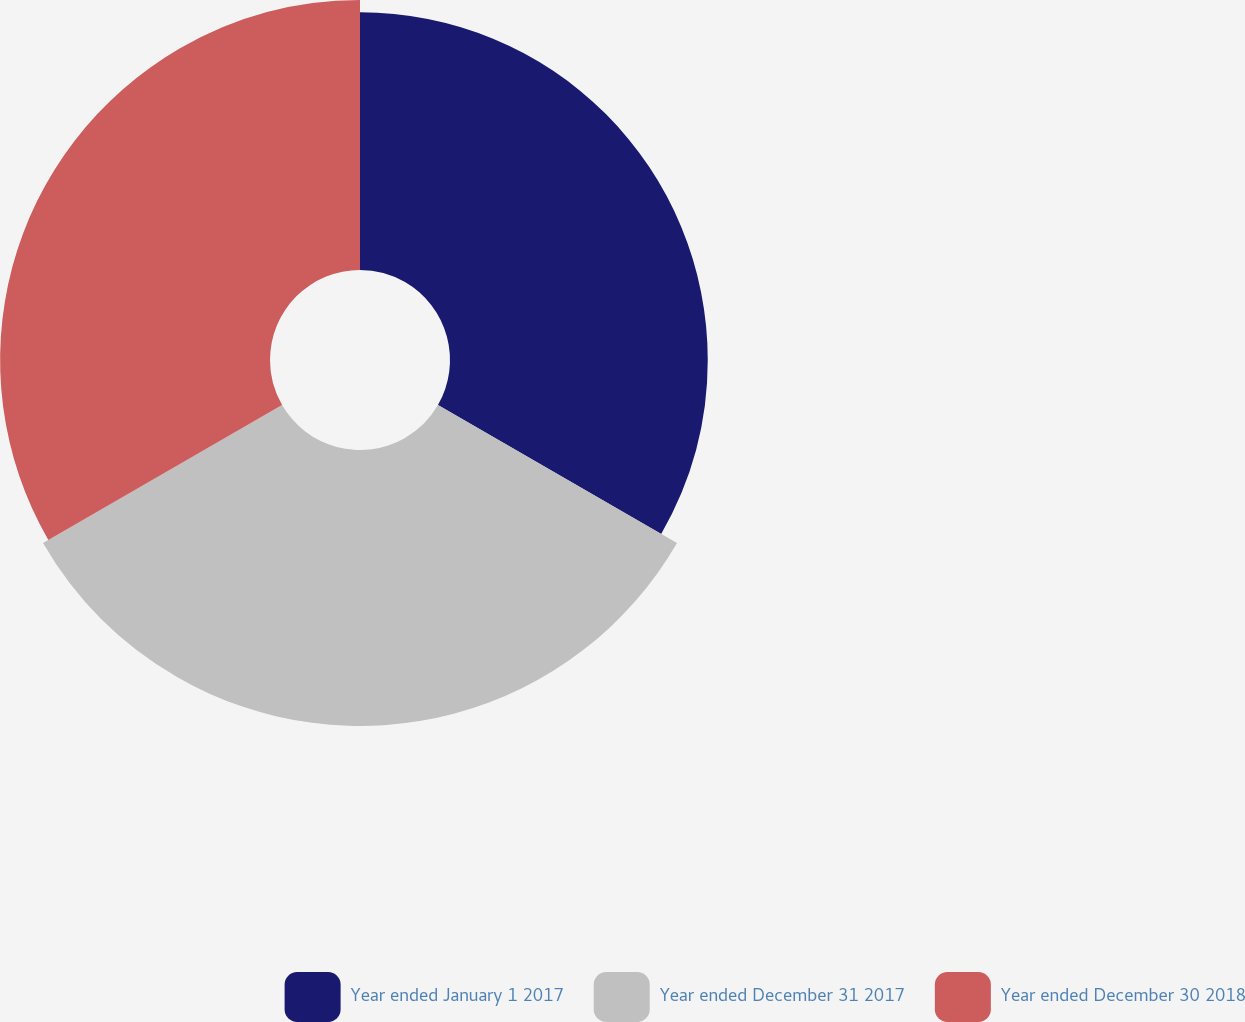Convert chart to OTSL. <chart><loc_0><loc_0><loc_500><loc_500><pie_chart><fcel>Year ended January 1 2017<fcel>Year ended December 31 2017<fcel>Year ended December 30 2018<nl><fcel>32.07%<fcel>34.34%<fcel>33.58%<nl></chart> 